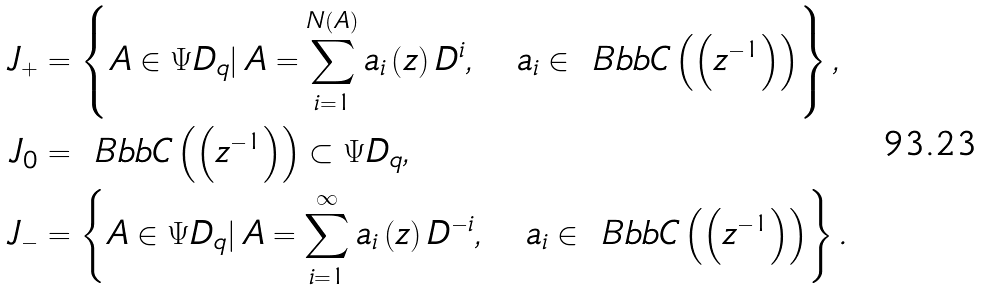<formula> <loc_0><loc_0><loc_500><loc_500>J _ { + } & = \left \{ A \in \Psi { D } _ { q } | \, A = \sum _ { i = 1 } ^ { N \left ( A \right ) } a _ { i } \left ( z \right ) D ^ { i } , \quad a _ { i } \in { \ B b b C } \left ( \left ( z ^ { - 1 } \right ) \right ) \right \} , \\ J _ { 0 } & = { \ B b b C } \left ( \left ( z ^ { - 1 } \right ) \right ) \subset \Psi { D } _ { q } , \\ J _ { - } & = \left \{ A \in \Psi { D } _ { q } | \, A = \sum _ { i = 1 } ^ { \infty } a _ { i } \left ( z \right ) D ^ { - i } , \quad a _ { i } \in { \ B b b C } \left ( \left ( z ^ { - 1 } \right ) \right ) \right \} .</formula> 